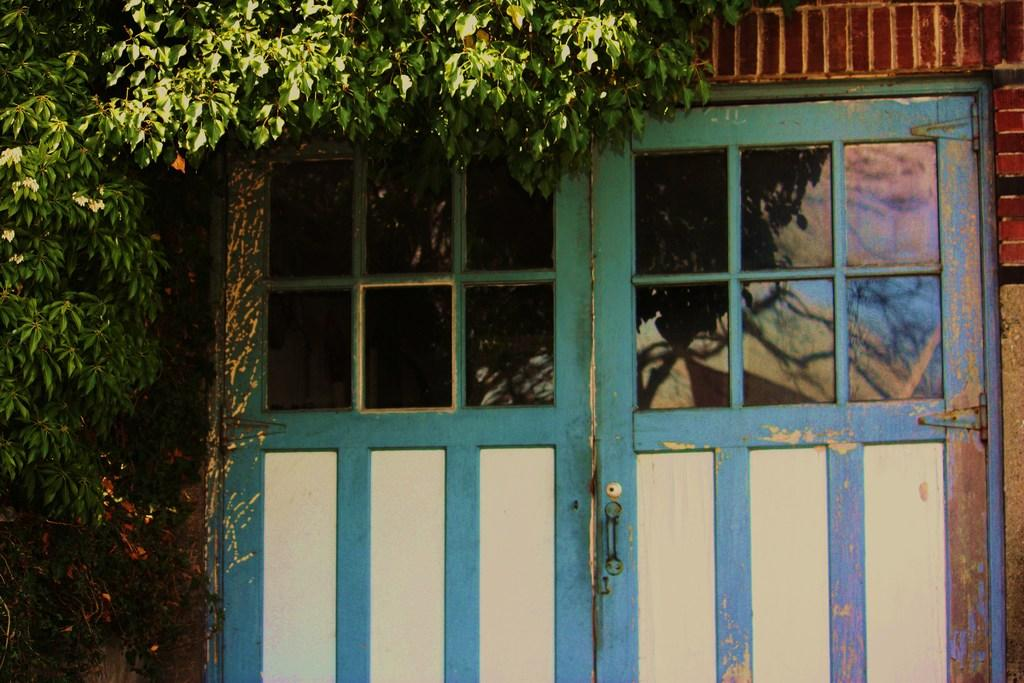What type of plant is on the left side of the image? There is a tree with green leaves on the left side of the image. What is the tree's proximity to a man-made structure? The tree is near a building. What feature can be observed on the doors of the building? The doors of the building have glass. How many jellyfish are visible in the image? There are no jellyfish present in the image. What type of camera is being used to take the picture? The facts provided do not mention any camera or photography equipment, so it cannot be determined from the image. 